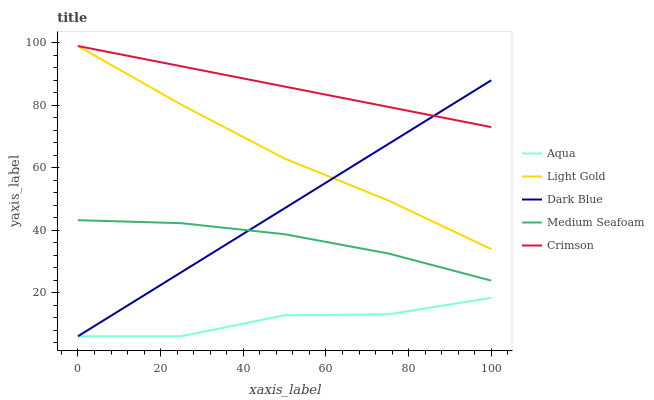Does Aqua have the minimum area under the curve?
Answer yes or no. Yes. Does Crimson have the maximum area under the curve?
Answer yes or no. Yes. Does Light Gold have the minimum area under the curve?
Answer yes or no. No. Does Light Gold have the maximum area under the curve?
Answer yes or no. No. Is Crimson the smoothest?
Answer yes or no. Yes. Is Aqua the roughest?
Answer yes or no. Yes. Is Light Gold the smoothest?
Answer yes or no. No. Is Light Gold the roughest?
Answer yes or no. No. Does Aqua have the lowest value?
Answer yes or no. Yes. Does Light Gold have the lowest value?
Answer yes or no. No. Does Light Gold have the highest value?
Answer yes or no. Yes. Does Aqua have the highest value?
Answer yes or no. No. Is Medium Seafoam less than Crimson?
Answer yes or no. Yes. Is Crimson greater than Medium Seafoam?
Answer yes or no. Yes. Does Light Gold intersect Crimson?
Answer yes or no. Yes. Is Light Gold less than Crimson?
Answer yes or no. No. Is Light Gold greater than Crimson?
Answer yes or no. No. Does Medium Seafoam intersect Crimson?
Answer yes or no. No. 